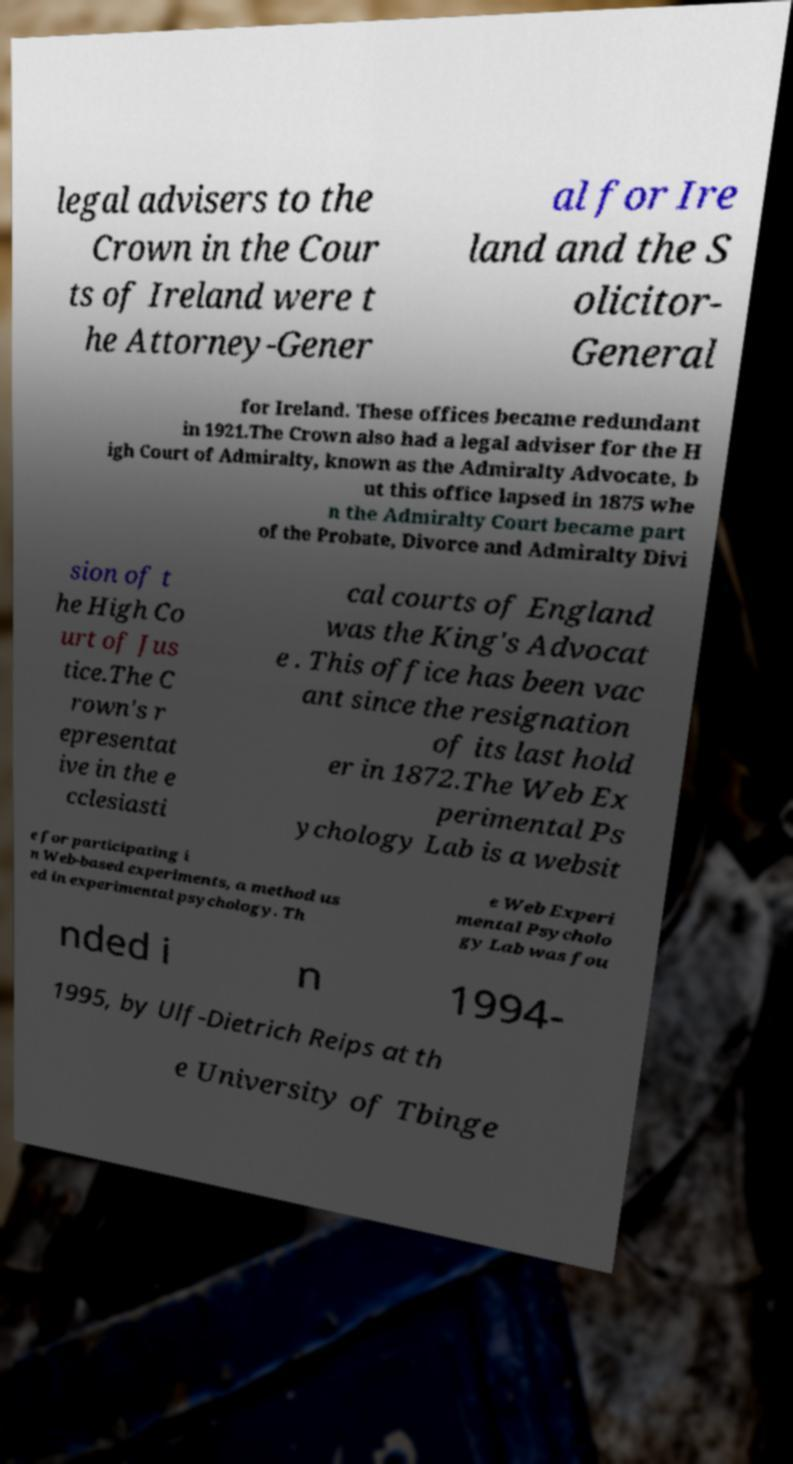Can you accurately transcribe the text from the provided image for me? legal advisers to the Crown in the Cour ts of Ireland were t he Attorney-Gener al for Ire land and the S olicitor- General for Ireland. These offices became redundant in 1921.The Crown also had a legal adviser for the H igh Court of Admiralty, known as the Admiralty Advocate, b ut this office lapsed in 1875 whe n the Admiralty Court became part of the Probate, Divorce and Admiralty Divi sion of t he High Co urt of Jus tice.The C rown's r epresentat ive in the e cclesiasti cal courts of England was the King's Advocat e . This office has been vac ant since the resignation of its last hold er in 1872.The Web Ex perimental Ps ychology Lab is a websit e for participating i n Web-based experiments, a method us ed in experimental psychology. Th e Web Experi mental Psycholo gy Lab was fou nded i n 1994- 1995, by Ulf-Dietrich Reips at th e University of Tbinge 